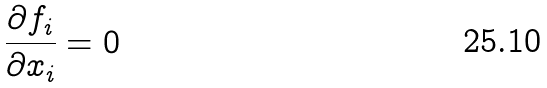<formula> <loc_0><loc_0><loc_500><loc_500>\frac { \partial f _ { i } } { \partial x _ { i } } = 0</formula> 